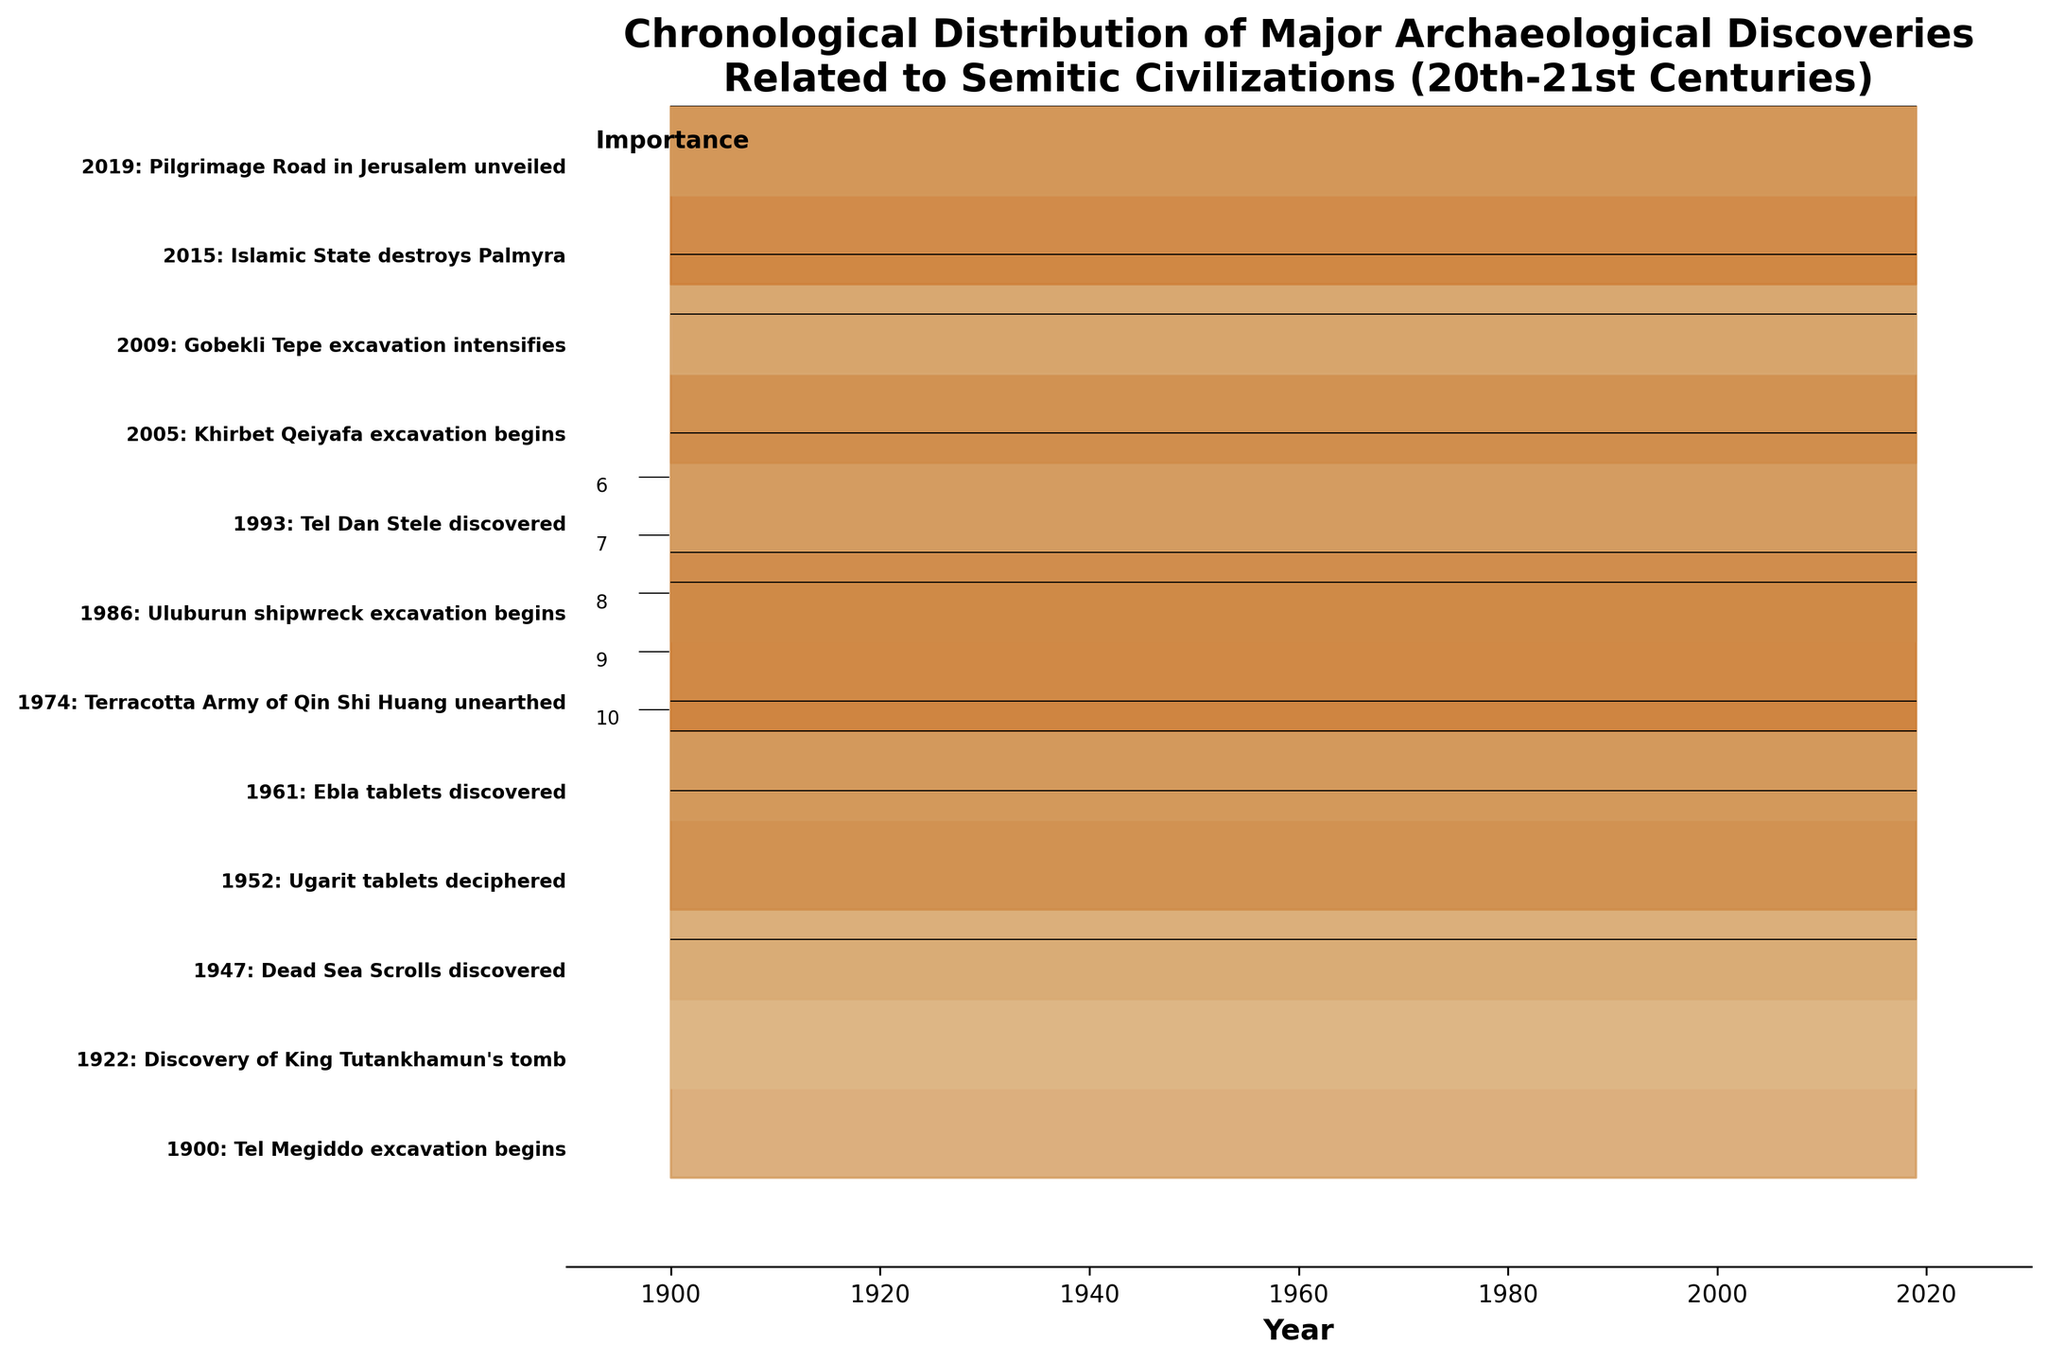What year did the Khirbet Qeiyafa excavation begin? The Khirbet Qeiyafa excavation is labeled on the ridgeline plot, indicating the year it began. Look for the text "Khirbet Qeiyafa excavation begins" and the corresponding year beside it.
Answer: 2005 What is the title of the plot? The title is prominently displayed at the top of the plot. It provides a summary of what the plot is about.
Answer: Chronological Distribution of Major Archaeological Discoveries Related to Semitic Civilizations (20th-21st Centuries) Which discovery is marked with the highest importance, and in what year was it discovered? The importance of each discovery is visually represented by the height of the ridgeline, with the color indicating the importance level. The discovery with the highest importance will have the tallest and darkest ridge. Check the corresponding label for the year.
Answer: Discovery of King Tutankhamun's tomb in 1922 How many archaeological discoveries are depicted in the plot? Count the number of labeled discoveries on the ridgeline plot. Each discovery is marked with a text label indicating the year and name.
Answer: 11 What is the average importance level of the discoveries listed? Sum the importance levels of all the discoveries and divide by the number of discoveries. The importance levels are: 8, 10, 9, 7, 8, 6, 7, 8, 7, 9, 6. Calculate the average as follows: (8+10+9+7+8+6+7+8+7+9+6)/11.
Answer: 7.64 Between the discoveries in 1947 and 1961, which one has higher importance? Compare the importance levels of the discoveries made in 1947 and 1961. The plot shows "Dead Sea Scrolls discovered" in 1947 with an importance of 9 and "Ebla tablets discovered" in 1961 with an importance of 8.
Answer: The discovery in 1947 What is the range of years covered by the discoveries in this plot? Look at the earliest and latest years labeled on the plot. Identify the minimum and maximum years from the labeled discoveries.
Answer: 1900 to 2019 Which discovery in the 21st century has the highest importance, and what is its value? Identify the discoveries made from 2001 onwards and compare their importance levels. Look for the tallest and darkest ridge in this period.
Answer: Gobekli Tepe excavation intensifies in 2009, with an importance of 9 Which year had the discovery of the Tel Dan Stele, and what was its importance level? Locate the Tel Dan Stele label on the plot and note its corresponding year and importance level.
Answer: 1993, with an importance of 8 